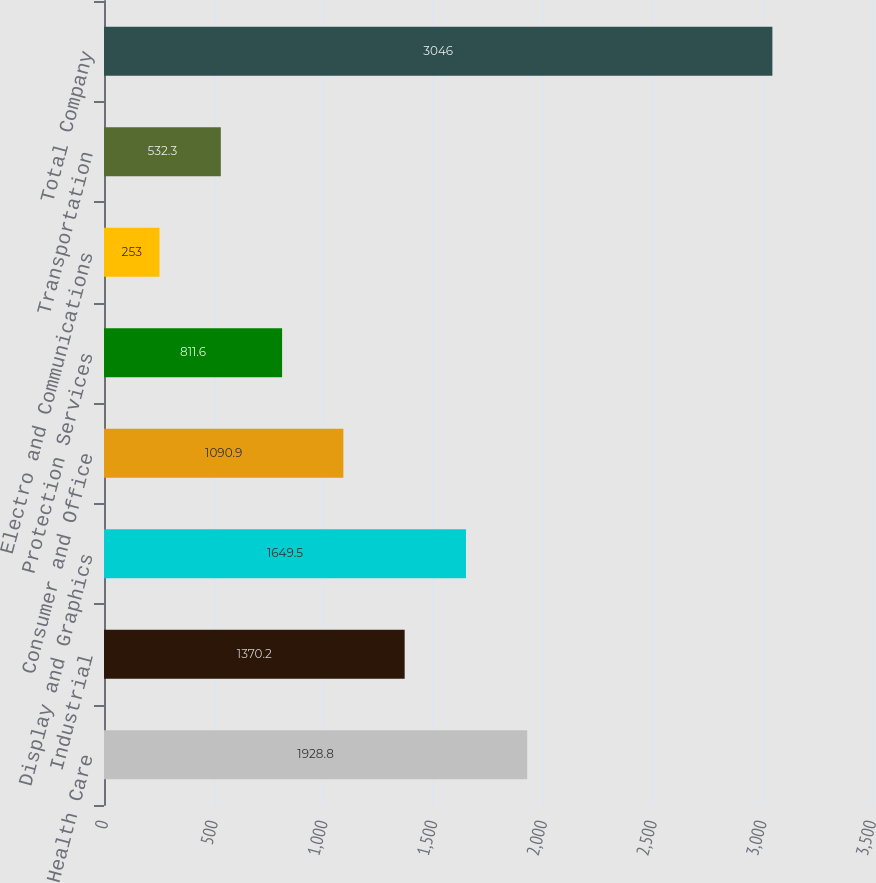Convert chart to OTSL. <chart><loc_0><loc_0><loc_500><loc_500><bar_chart><fcel>Health Care<fcel>Industrial<fcel>Display and Graphics<fcel>Consumer and Office<fcel>Protection Services<fcel>Electro and Communications<fcel>Transportation<fcel>Total Company<nl><fcel>1928.8<fcel>1370.2<fcel>1649.5<fcel>1090.9<fcel>811.6<fcel>253<fcel>532.3<fcel>3046<nl></chart> 